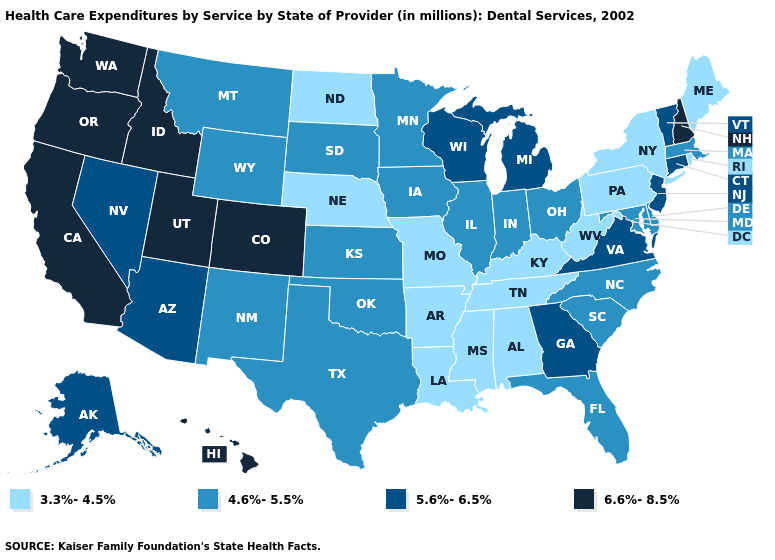What is the lowest value in the MidWest?
Give a very brief answer. 3.3%-4.5%. Does North Dakota have the lowest value in the USA?
Keep it brief. Yes. What is the value of Idaho?
Write a very short answer. 6.6%-8.5%. What is the highest value in the West ?
Short answer required. 6.6%-8.5%. Does Tennessee have the highest value in the USA?
Give a very brief answer. No. What is the lowest value in states that border Minnesota?
Be succinct. 3.3%-4.5%. What is the value of New Mexico?
Write a very short answer. 4.6%-5.5%. What is the highest value in the USA?
Short answer required. 6.6%-8.5%. Among the states that border West Virginia , does Kentucky have the lowest value?
Quick response, please. Yes. What is the value of Indiana?
Concise answer only. 4.6%-5.5%. Which states have the lowest value in the MidWest?
Keep it brief. Missouri, Nebraska, North Dakota. Does Vermont have the same value as Alabama?
Be succinct. No. Name the states that have a value in the range 3.3%-4.5%?
Quick response, please. Alabama, Arkansas, Kentucky, Louisiana, Maine, Mississippi, Missouri, Nebraska, New York, North Dakota, Pennsylvania, Rhode Island, Tennessee, West Virginia. Which states have the lowest value in the South?
Quick response, please. Alabama, Arkansas, Kentucky, Louisiana, Mississippi, Tennessee, West Virginia. What is the value of Minnesota?
Quick response, please. 4.6%-5.5%. 